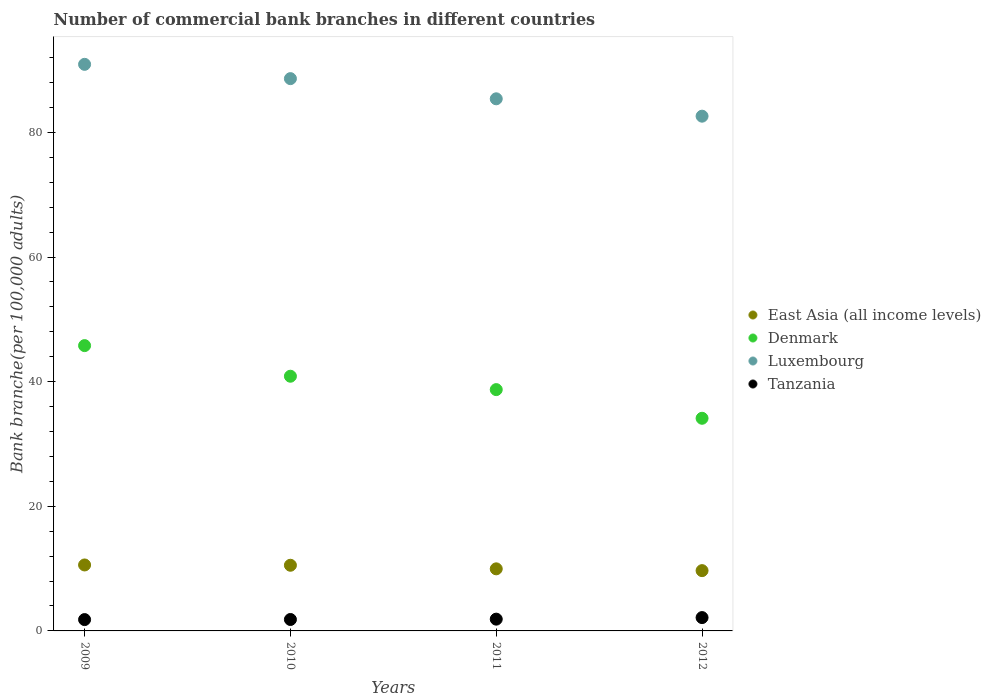Is the number of dotlines equal to the number of legend labels?
Your response must be concise. Yes. What is the number of commercial bank branches in East Asia (all income levels) in 2012?
Ensure brevity in your answer.  9.67. Across all years, what is the maximum number of commercial bank branches in Luxembourg?
Provide a short and direct response. 90.92. Across all years, what is the minimum number of commercial bank branches in Denmark?
Keep it short and to the point. 34.12. What is the total number of commercial bank branches in Luxembourg in the graph?
Offer a terse response. 347.52. What is the difference between the number of commercial bank branches in Tanzania in 2009 and that in 2010?
Your response must be concise. -0.02. What is the difference between the number of commercial bank branches in East Asia (all income levels) in 2011 and the number of commercial bank branches in Denmark in 2009?
Ensure brevity in your answer.  -35.82. What is the average number of commercial bank branches in Tanzania per year?
Your response must be concise. 1.92. In the year 2009, what is the difference between the number of commercial bank branches in East Asia (all income levels) and number of commercial bank branches in Tanzania?
Your answer should be very brief. 8.77. In how many years, is the number of commercial bank branches in Luxembourg greater than 4?
Your answer should be very brief. 4. What is the ratio of the number of commercial bank branches in Tanzania in 2009 to that in 2012?
Make the answer very short. 0.85. Is the difference between the number of commercial bank branches in East Asia (all income levels) in 2010 and 2012 greater than the difference between the number of commercial bank branches in Tanzania in 2010 and 2012?
Provide a succinct answer. Yes. What is the difference between the highest and the second highest number of commercial bank branches in Luxembourg?
Offer a terse response. 2.29. What is the difference between the highest and the lowest number of commercial bank branches in Denmark?
Make the answer very short. 11.66. Is it the case that in every year, the sum of the number of commercial bank branches in Tanzania and number of commercial bank branches in Luxembourg  is greater than the sum of number of commercial bank branches in Denmark and number of commercial bank branches in East Asia (all income levels)?
Offer a very short reply. Yes. Is it the case that in every year, the sum of the number of commercial bank branches in East Asia (all income levels) and number of commercial bank branches in Tanzania  is greater than the number of commercial bank branches in Denmark?
Provide a short and direct response. No. Is the number of commercial bank branches in Denmark strictly greater than the number of commercial bank branches in Tanzania over the years?
Provide a short and direct response. Yes. How many dotlines are there?
Your answer should be compact. 4. How many years are there in the graph?
Ensure brevity in your answer.  4. Are the values on the major ticks of Y-axis written in scientific E-notation?
Keep it short and to the point. No. How many legend labels are there?
Your answer should be compact. 4. How are the legend labels stacked?
Provide a succinct answer. Vertical. What is the title of the graph?
Keep it short and to the point. Number of commercial bank branches in different countries. What is the label or title of the Y-axis?
Your answer should be very brief. Bank branche(per 100,0 adults). What is the Bank branche(per 100,000 adults) in East Asia (all income levels) in 2009?
Your answer should be very brief. 10.58. What is the Bank branche(per 100,000 adults) in Denmark in 2009?
Provide a succinct answer. 45.78. What is the Bank branche(per 100,000 adults) of Luxembourg in 2009?
Your response must be concise. 90.92. What is the Bank branche(per 100,000 adults) in Tanzania in 2009?
Make the answer very short. 1.82. What is the Bank branche(per 100,000 adults) in East Asia (all income levels) in 2010?
Offer a terse response. 10.54. What is the Bank branche(per 100,000 adults) in Denmark in 2010?
Your answer should be compact. 40.87. What is the Bank branche(per 100,000 adults) of Luxembourg in 2010?
Offer a very short reply. 88.62. What is the Bank branche(per 100,000 adults) in Tanzania in 2010?
Give a very brief answer. 1.83. What is the Bank branche(per 100,000 adults) of East Asia (all income levels) in 2011?
Your answer should be very brief. 9.96. What is the Bank branche(per 100,000 adults) of Denmark in 2011?
Ensure brevity in your answer.  38.72. What is the Bank branche(per 100,000 adults) of Luxembourg in 2011?
Offer a terse response. 85.38. What is the Bank branche(per 100,000 adults) in Tanzania in 2011?
Your response must be concise. 1.89. What is the Bank branche(per 100,000 adults) in East Asia (all income levels) in 2012?
Ensure brevity in your answer.  9.67. What is the Bank branche(per 100,000 adults) in Denmark in 2012?
Your response must be concise. 34.12. What is the Bank branche(per 100,000 adults) in Luxembourg in 2012?
Keep it short and to the point. 82.6. What is the Bank branche(per 100,000 adults) in Tanzania in 2012?
Make the answer very short. 2.14. Across all years, what is the maximum Bank branche(per 100,000 adults) in East Asia (all income levels)?
Your response must be concise. 10.58. Across all years, what is the maximum Bank branche(per 100,000 adults) of Denmark?
Provide a short and direct response. 45.78. Across all years, what is the maximum Bank branche(per 100,000 adults) in Luxembourg?
Make the answer very short. 90.92. Across all years, what is the maximum Bank branche(per 100,000 adults) of Tanzania?
Provide a succinct answer. 2.14. Across all years, what is the minimum Bank branche(per 100,000 adults) of East Asia (all income levels)?
Your answer should be compact. 9.67. Across all years, what is the minimum Bank branche(per 100,000 adults) in Denmark?
Your answer should be compact. 34.12. Across all years, what is the minimum Bank branche(per 100,000 adults) in Luxembourg?
Provide a succinct answer. 82.6. Across all years, what is the minimum Bank branche(per 100,000 adults) of Tanzania?
Give a very brief answer. 1.82. What is the total Bank branche(per 100,000 adults) in East Asia (all income levels) in the graph?
Provide a succinct answer. 40.76. What is the total Bank branche(per 100,000 adults) in Denmark in the graph?
Provide a succinct answer. 159.49. What is the total Bank branche(per 100,000 adults) of Luxembourg in the graph?
Make the answer very short. 347.52. What is the total Bank branche(per 100,000 adults) in Tanzania in the graph?
Ensure brevity in your answer.  7.68. What is the difference between the Bank branche(per 100,000 adults) of East Asia (all income levels) in 2009 and that in 2010?
Offer a very short reply. 0.05. What is the difference between the Bank branche(per 100,000 adults) in Denmark in 2009 and that in 2010?
Give a very brief answer. 4.91. What is the difference between the Bank branche(per 100,000 adults) of Luxembourg in 2009 and that in 2010?
Provide a succinct answer. 2.29. What is the difference between the Bank branche(per 100,000 adults) of Tanzania in 2009 and that in 2010?
Your answer should be very brief. -0.02. What is the difference between the Bank branche(per 100,000 adults) in East Asia (all income levels) in 2009 and that in 2011?
Your answer should be very brief. 0.62. What is the difference between the Bank branche(per 100,000 adults) of Denmark in 2009 and that in 2011?
Offer a terse response. 7.06. What is the difference between the Bank branche(per 100,000 adults) of Luxembourg in 2009 and that in 2011?
Keep it short and to the point. 5.53. What is the difference between the Bank branche(per 100,000 adults) of Tanzania in 2009 and that in 2011?
Give a very brief answer. -0.07. What is the difference between the Bank branche(per 100,000 adults) in East Asia (all income levels) in 2009 and that in 2012?
Offer a very short reply. 0.91. What is the difference between the Bank branche(per 100,000 adults) of Denmark in 2009 and that in 2012?
Make the answer very short. 11.66. What is the difference between the Bank branche(per 100,000 adults) of Luxembourg in 2009 and that in 2012?
Offer a very short reply. 8.32. What is the difference between the Bank branche(per 100,000 adults) of Tanzania in 2009 and that in 2012?
Provide a short and direct response. -0.32. What is the difference between the Bank branche(per 100,000 adults) in East Asia (all income levels) in 2010 and that in 2011?
Your response must be concise. 0.58. What is the difference between the Bank branche(per 100,000 adults) of Denmark in 2010 and that in 2011?
Provide a succinct answer. 2.15. What is the difference between the Bank branche(per 100,000 adults) of Luxembourg in 2010 and that in 2011?
Your response must be concise. 3.24. What is the difference between the Bank branche(per 100,000 adults) of Tanzania in 2010 and that in 2011?
Offer a very short reply. -0.06. What is the difference between the Bank branche(per 100,000 adults) in East Asia (all income levels) in 2010 and that in 2012?
Your answer should be compact. 0.86. What is the difference between the Bank branche(per 100,000 adults) of Denmark in 2010 and that in 2012?
Your answer should be very brief. 6.75. What is the difference between the Bank branche(per 100,000 adults) in Luxembourg in 2010 and that in 2012?
Provide a short and direct response. 6.02. What is the difference between the Bank branche(per 100,000 adults) of Tanzania in 2010 and that in 2012?
Make the answer very short. -0.31. What is the difference between the Bank branche(per 100,000 adults) in East Asia (all income levels) in 2011 and that in 2012?
Offer a terse response. 0.29. What is the difference between the Bank branche(per 100,000 adults) in Denmark in 2011 and that in 2012?
Make the answer very short. 4.6. What is the difference between the Bank branche(per 100,000 adults) of Luxembourg in 2011 and that in 2012?
Make the answer very short. 2.79. What is the difference between the Bank branche(per 100,000 adults) of Tanzania in 2011 and that in 2012?
Give a very brief answer. -0.25. What is the difference between the Bank branche(per 100,000 adults) of East Asia (all income levels) in 2009 and the Bank branche(per 100,000 adults) of Denmark in 2010?
Your answer should be very brief. -30.28. What is the difference between the Bank branche(per 100,000 adults) in East Asia (all income levels) in 2009 and the Bank branche(per 100,000 adults) in Luxembourg in 2010?
Make the answer very short. -78.04. What is the difference between the Bank branche(per 100,000 adults) in East Asia (all income levels) in 2009 and the Bank branche(per 100,000 adults) in Tanzania in 2010?
Your answer should be very brief. 8.75. What is the difference between the Bank branche(per 100,000 adults) in Denmark in 2009 and the Bank branche(per 100,000 adults) in Luxembourg in 2010?
Provide a short and direct response. -42.84. What is the difference between the Bank branche(per 100,000 adults) of Denmark in 2009 and the Bank branche(per 100,000 adults) of Tanzania in 2010?
Offer a very short reply. 43.95. What is the difference between the Bank branche(per 100,000 adults) in Luxembourg in 2009 and the Bank branche(per 100,000 adults) in Tanzania in 2010?
Your answer should be very brief. 89.08. What is the difference between the Bank branche(per 100,000 adults) in East Asia (all income levels) in 2009 and the Bank branche(per 100,000 adults) in Denmark in 2011?
Make the answer very short. -28.14. What is the difference between the Bank branche(per 100,000 adults) of East Asia (all income levels) in 2009 and the Bank branche(per 100,000 adults) of Luxembourg in 2011?
Keep it short and to the point. -74.8. What is the difference between the Bank branche(per 100,000 adults) of East Asia (all income levels) in 2009 and the Bank branche(per 100,000 adults) of Tanzania in 2011?
Ensure brevity in your answer.  8.69. What is the difference between the Bank branche(per 100,000 adults) of Denmark in 2009 and the Bank branche(per 100,000 adults) of Luxembourg in 2011?
Keep it short and to the point. -39.6. What is the difference between the Bank branche(per 100,000 adults) of Denmark in 2009 and the Bank branche(per 100,000 adults) of Tanzania in 2011?
Provide a short and direct response. 43.89. What is the difference between the Bank branche(per 100,000 adults) of Luxembourg in 2009 and the Bank branche(per 100,000 adults) of Tanzania in 2011?
Offer a very short reply. 89.03. What is the difference between the Bank branche(per 100,000 adults) in East Asia (all income levels) in 2009 and the Bank branche(per 100,000 adults) in Denmark in 2012?
Offer a very short reply. -23.54. What is the difference between the Bank branche(per 100,000 adults) of East Asia (all income levels) in 2009 and the Bank branche(per 100,000 adults) of Luxembourg in 2012?
Your answer should be very brief. -72.01. What is the difference between the Bank branche(per 100,000 adults) in East Asia (all income levels) in 2009 and the Bank branche(per 100,000 adults) in Tanzania in 2012?
Offer a very short reply. 8.44. What is the difference between the Bank branche(per 100,000 adults) in Denmark in 2009 and the Bank branche(per 100,000 adults) in Luxembourg in 2012?
Your answer should be compact. -36.82. What is the difference between the Bank branche(per 100,000 adults) in Denmark in 2009 and the Bank branche(per 100,000 adults) in Tanzania in 2012?
Ensure brevity in your answer.  43.64. What is the difference between the Bank branche(per 100,000 adults) in Luxembourg in 2009 and the Bank branche(per 100,000 adults) in Tanzania in 2012?
Your response must be concise. 88.78. What is the difference between the Bank branche(per 100,000 adults) in East Asia (all income levels) in 2010 and the Bank branche(per 100,000 adults) in Denmark in 2011?
Offer a very short reply. -28.18. What is the difference between the Bank branche(per 100,000 adults) of East Asia (all income levels) in 2010 and the Bank branche(per 100,000 adults) of Luxembourg in 2011?
Provide a short and direct response. -74.85. What is the difference between the Bank branche(per 100,000 adults) in East Asia (all income levels) in 2010 and the Bank branche(per 100,000 adults) in Tanzania in 2011?
Give a very brief answer. 8.65. What is the difference between the Bank branche(per 100,000 adults) in Denmark in 2010 and the Bank branche(per 100,000 adults) in Luxembourg in 2011?
Keep it short and to the point. -44.52. What is the difference between the Bank branche(per 100,000 adults) in Denmark in 2010 and the Bank branche(per 100,000 adults) in Tanzania in 2011?
Your answer should be compact. 38.98. What is the difference between the Bank branche(per 100,000 adults) in Luxembourg in 2010 and the Bank branche(per 100,000 adults) in Tanzania in 2011?
Provide a succinct answer. 86.73. What is the difference between the Bank branche(per 100,000 adults) in East Asia (all income levels) in 2010 and the Bank branche(per 100,000 adults) in Denmark in 2012?
Your response must be concise. -23.58. What is the difference between the Bank branche(per 100,000 adults) of East Asia (all income levels) in 2010 and the Bank branche(per 100,000 adults) of Luxembourg in 2012?
Offer a very short reply. -72.06. What is the difference between the Bank branche(per 100,000 adults) in East Asia (all income levels) in 2010 and the Bank branche(per 100,000 adults) in Tanzania in 2012?
Keep it short and to the point. 8.4. What is the difference between the Bank branche(per 100,000 adults) in Denmark in 2010 and the Bank branche(per 100,000 adults) in Luxembourg in 2012?
Your answer should be very brief. -41.73. What is the difference between the Bank branche(per 100,000 adults) in Denmark in 2010 and the Bank branche(per 100,000 adults) in Tanzania in 2012?
Provide a short and direct response. 38.73. What is the difference between the Bank branche(per 100,000 adults) in Luxembourg in 2010 and the Bank branche(per 100,000 adults) in Tanzania in 2012?
Offer a terse response. 86.48. What is the difference between the Bank branche(per 100,000 adults) of East Asia (all income levels) in 2011 and the Bank branche(per 100,000 adults) of Denmark in 2012?
Ensure brevity in your answer.  -24.16. What is the difference between the Bank branche(per 100,000 adults) of East Asia (all income levels) in 2011 and the Bank branche(per 100,000 adults) of Luxembourg in 2012?
Offer a very short reply. -72.64. What is the difference between the Bank branche(per 100,000 adults) of East Asia (all income levels) in 2011 and the Bank branche(per 100,000 adults) of Tanzania in 2012?
Your response must be concise. 7.82. What is the difference between the Bank branche(per 100,000 adults) of Denmark in 2011 and the Bank branche(per 100,000 adults) of Luxembourg in 2012?
Provide a succinct answer. -43.88. What is the difference between the Bank branche(per 100,000 adults) of Denmark in 2011 and the Bank branche(per 100,000 adults) of Tanzania in 2012?
Ensure brevity in your answer.  36.58. What is the difference between the Bank branche(per 100,000 adults) of Luxembourg in 2011 and the Bank branche(per 100,000 adults) of Tanzania in 2012?
Your response must be concise. 83.24. What is the average Bank branche(per 100,000 adults) of East Asia (all income levels) per year?
Provide a short and direct response. 10.19. What is the average Bank branche(per 100,000 adults) of Denmark per year?
Give a very brief answer. 39.87. What is the average Bank branche(per 100,000 adults) of Luxembourg per year?
Make the answer very short. 86.88. What is the average Bank branche(per 100,000 adults) in Tanzania per year?
Offer a very short reply. 1.92. In the year 2009, what is the difference between the Bank branche(per 100,000 adults) of East Asia (all income levels) and Bank branche(per 100,000 adults) of Denmark?
Offer a very short reply. -35.2. In the year 2009, what is the difference between the Bank branche(per 100,000 adults) of East Asia (all income levels) and Bank branche(per 100,000 adults) of Luxembourg?
Your response must be concise. -80.33. In the year 2009, what is the difference between the Bank branche(per 100,000 adults) in East Asia (all income levels) and Bank branche(per 100,000 adults) in Tanzania?
Offer a terse response. 8.77. In the year 2009, what is the difference between the Bank branche(per 100,000 adults) of Denmark and Bank branche(per 100,000 adults) of Luxembourg?
Make the answer very short. -45.13. In the year 2009, what is the difference between the Bank branche(per 100,000 adults) of Denmark and Bank branche(per 100,000 adults) of Tanzania?
Offer a terse response. 43.96. In the year 2009, what is the difference between the Bank branche(per 100,000 adults) in Luxembourg and Bank branche(per 100,000 adults) in Tanzania?
Offer a very short reply. 89.1. In the year 2010, what is the difference between the Bank branche(per 100,000 adults) of East Asia (all income levels) and Bank branche(per 100,000 adults) of Denmark?
Keep it short and to the point. -30.33. In the year 2010, what is the difference between the Bank branche(per 100,000 adults) in East Asia (all income levels) and Bank branche(per 100,000 adults) in Luxembourg?
Keep it short and to the point. -78.08. In the year 2010, what is the difference between the Bank branche(per 100,000 adults) in East Asia (all income levels) and Bank branche(per 100,000 adults) in Tanzania?
Keep it short and to the point. 8.7. In the year 2010, what is the difference between the Bank branche(per 100,000 adults) in Denmark and Bank branche(per 100,000 adults) in Luxembourg?
Offer a very short reply. -47.75. In the year 2010, what is the difference between the Bank branche(per 100,000 adults) of Denmark and Bank branche(per 100,000 adults) of Tanzania?
Provide a short and direct response. 39.03. In the year 2010, what is the difference between the Bank branche(per 100,000 adults) of Luxembourg and Bank branche(per 100,000 adults) of Tanzania?
Your response must be concise. 86.79. In the year 2011, what is the difference between the Bank branche(per 100,000 adults) in East Asia (all income levels) and Bank branche(per 100,000 adults) in Denmark?
Make the answer very short. -28.76. In the year 2011, what is the difference between the Bank branche(per 100,000 adults) of East Asia (all income levels) and Bank branche(per 100,000 adults) of Luxembourg?
Give a very brief answer. -75.42. In the year 2011, what is the difference between the Bank branche(per 100,000 adults) of East Asia (all income levels) and Bank branche(per 100,000 adults) of Tanzania?
Keep it short and to the point. 8.07. In the year 2011, what is the difference between the Bank branche(per 100,000 adults) of Denmark and Bank branche(per 100,000 adults) of Luxembourg?
Your answer should be compact. -46.66. In the year 2011, what is the difference between the Bank branche(per 100,000 adults) of Denmark and Bank branche(per 100,000 adults) of Tanzania?
Offer a very short reply. 36.83. In the year 2011, what is the difference between the Bank branche(per 100,000 adults) of Luxembourg and Bank branche(per 100,000 adults) of Tanzania?
Make the answer very short. 83.49. In the year 2012, what is the difference between the Bank branche(per 100,000 adults) of East Asia (all income levels) and Bank branche(per 100,000 adults) of Denmark?
Keep it short and to the point. -24.45. In the year 2012, what is the difference between the Bank branche(per 100,000 adults) of East Asia (all income levels) and Bank branche(per 100,000 adults) of Luxembourg?
Your answer should be very brief. -72.92. In the year 2012, what is the difference between the Bank branche(per 100,000 adults) of East Asia (all income levels) and Bank branche(per 100,000 adults) of Tanzania?
Your answer should be very brief. 7.53. In the year 2012, what is the difference between the Bank branche(per 100,000 adults) of Denmark and Bank branche(per 100,000 adults) of Luxembourg?
Give a very brief answer. -48.48. In the year 2012, what is the difference between the Bank branche(per 100,000 adults) of Denmark and Bank branche(per 100,000 adults) of Tanzania?
Make the answer very short. 31.98. In the year 2012, what is the difference between the Bank branche(per 100,000 adults) of Luxembourg and Bank branche(per 100,000 adults) of Tanzania?
Provide a succinct answer. 80.46. What is the ratio of the Bank branche(per 100,000 adults) in East Asia (all income levels) in 2009 to that in 2010?
Keep it short and to the point. 1. What is the ratio of the Bank branche(per 100,000 adults) in Denmark in 2009 to that in 2010?
Offer a terse response. 1.12. What is the ratio of the Bank branche(per 100,000 adults) of Luxembourg in 2009 to that in 2010?
Make the answer very short. 1.03. What is the ratio of the Bank branche(per 100,000 adults) in Tanzania in 2009 to that in 2010?
Keep it short and to the point. 0.99. What is the ratio of the Bank branche(per 100,000 adults) of East Asia (all income levels) in 2009 to that in 2011?
Your response must be concise. 1.06. What is the ratio of the Bank branche(per 100,000 adults) of Denmark in 2009 to that in 2011?
Your response must be concise. 1.18. What is the ratio of the Bank branche(per 100,000 adults) of Luxembourg in 2009 to that in 2011?
Your response must be concise. 1.06. What is the ratio of the Bank branche(per 100,000 adults) of Tanzania in 2009 to that in 2011?
Provide a succinct answer. 0.96. What is the ratio of the Bank branche(per 100,000 adults) in East Asia (all income levels) in 2009 to that in 2012?
Give a very brief answer. 1.09. What is the ratio of the Bank branche(per 100,000 adults) in Denmark in 2009 to that in 2012?
Offer a very short reply. 1.34. What is the ratio of the Bank branche(per 100,000 adults) of Luxembourg in 2009 to that in 2012?
Give a very brief answer. 1.1. What is the ratio of the Bank branche(per 100,000 adults) in Tanzania in 2009 to that in 2012?
Offer a terse response. 0.85. What is the ratio of the Bank branche(per 100,000 adults) in East Asia (all income levels) in 2010 to that in 2011?
Make the answer very short. 1.06. What is the ratio of the Bank branche(per 100,000 adults) in Denmark in 2010 to that in 2011?
Offer a very short reply. 1.06. What is the ratio of the Bank branche(per 100,000 adults) in Luxembourg in 2010 to that in 2011?
Keep it short and to the point. 1.04. What is the ratio of the Bank branche(per 100,000 adults) of Tanzania in 2010 to that in 2011?
Keep it short and to the point. 0.97. What is the ratio of the Bank branche(per 100,000 adults) in East Asia (all income levels) in 2010 to that in 2012?
Offer a very short reply. 1.09. What is the ratio of the Bank branche(per 100,000 adults) of Denmark in 2010 to that in 2012?
Offer a very short reply. 1.2. What is the ratio of the Bank branche(per 100,000 adults) of Luxembourg in 2010 to that in 2012?
Give a very brief answer. 1.07. What is the ratio of the Bank branche(per 100,000 adults) in Tanzania in 2010 to that in 2012?
Offer a terse response. 0.86. What is the ratio of the Bank branche(per 100,000 adults) of East Asia (all income levels) in 2011 to that in 2012?
Give a very brief answer. 1.03. What is the ratio of the Bank branche(per 100,000 adults) of Denmark in 2011 to that in 2012?
Provide a short and direct response. 1.13. What is the ratio of the Bank branche(per 100,000 adults) in Luxembourg in 2011 to that in 2012?
Your response must be concise. 1.03. What is the ratio of the Bank branche(per 100,000 adults) in Tanzania in 2011 to that in 2012?
Offer a very short reply. 0.88. What is the difference between the highest and the second highest Bank branche(per 100,000 adults) in East Asia (all income levels)?
Give a very brief answer. 0.05. What is the difference between the highest and the second highest Bank branche(per 100,000 adults) of Denmark?
Your answer should be compact. 4.91. What is the difference between the highest and the second highest Bank branche(per 100,000 adults) of Luxembourg?
Your answer should be compact. 2.29. What is the difference between the highest and the second highest Bank branche(per 100,000 adults) of Tanzania?
Offer a very short reply. 0.25. What is the difference between the highest and the lowest Bank branche(per 100,000 adults) of East Asia (all income levels)?
Provide a short and direct response. 0.91. What is the difference between the highest and the lowest Bank branche(per 100,000 adults) of Denmark?
Ensure brevity in your answer.  11.66. What is the difference between the highest and the lowest Bank branche(per 100,000 adults) in Luxembourg?
Your answer should be very brief. 8.32. What is the difference between the highest and the lowest Bank branche(per 100,000 adults) of Tanzania?
Make the answer very short. 0.32. 